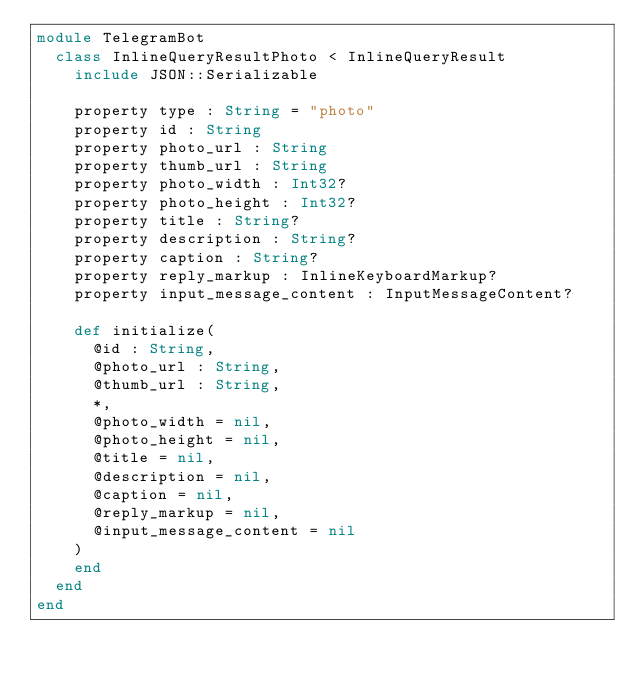Convert code to text. <code><loc_0><loc_0><loc_500><loc_500><_Crystal_>module TelegramBot
  class InlineQueryResultPhoto < InlineQueryResult
    include JSON::Serializable

    property type : String = "photo"
    property id : String
    property photo_url : String
    property thumb_url : String
    property photo_width : Int32?
    property photo_height : Int32?
    property title : String?
    property description : String?
    property caption : String?
    property reply_markup : InlineKeyboardMarkup?
    property input_message_content : InputMessageContent?

    def initialize(
      @id : String,
      @photo_url : String,
      @thumb_url : String,
      *,
      @photo_width = nil,
      @photo_height = nil,
      @title = nil,
      @description = nil,
      @caption = nil,
      @reply_markup = nil,
      @input_message_content = nil
    )
    end
  end
end
</code> 